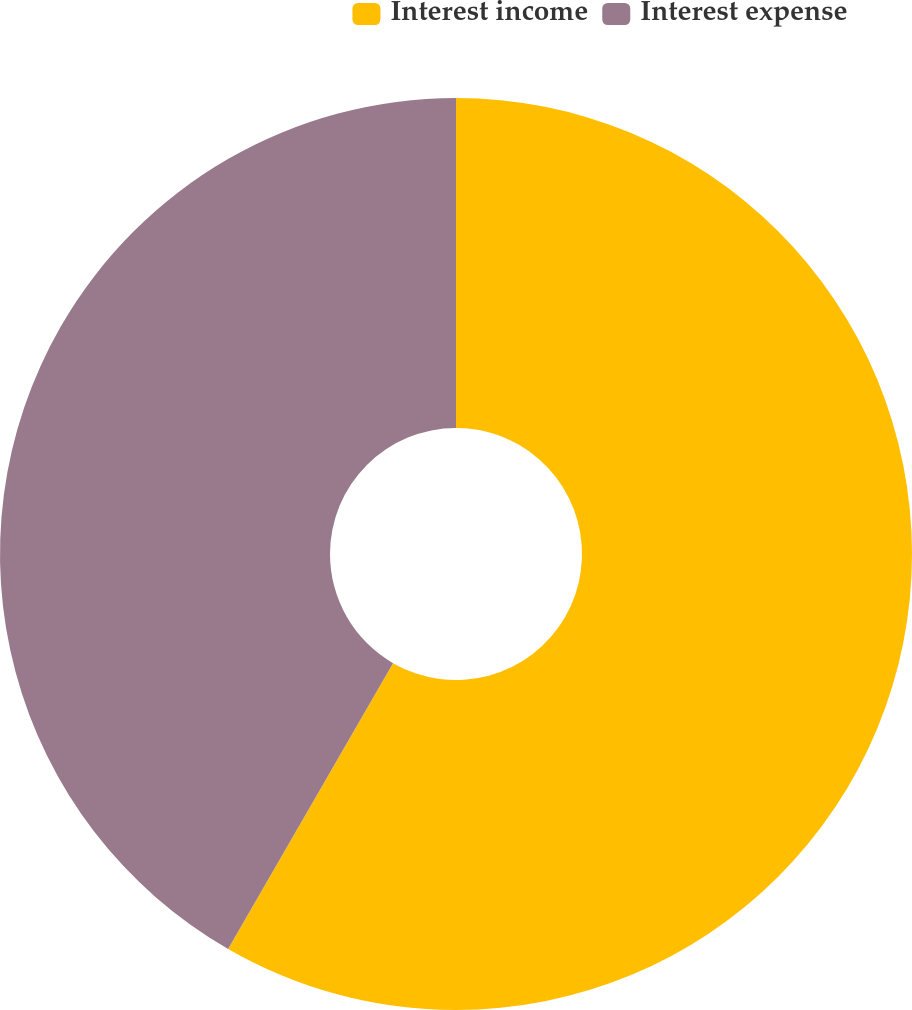Convert chart to OTSL. <chart><loc_0><loc_0><loc_500><loc_500><pie_chart><fcel>Interest income<fcel>Interest expense<nl><fcel>58.33%<fcel>41.67%<nl></chart> 